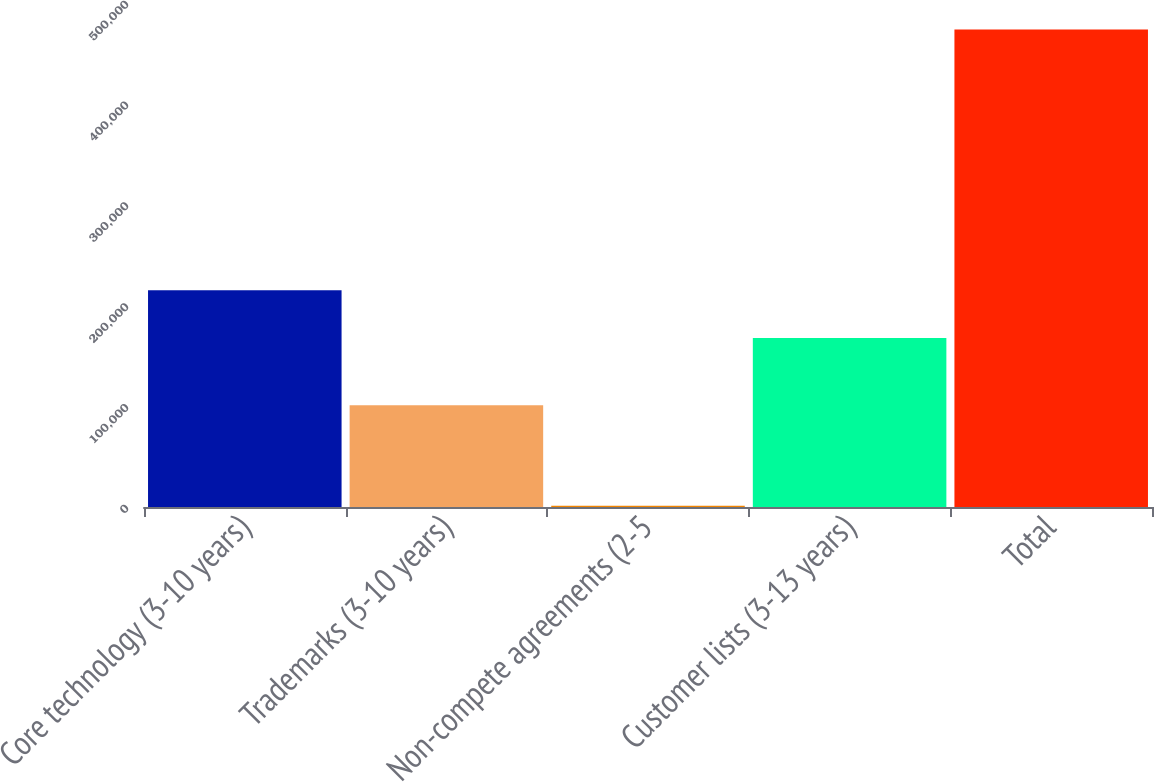<chart> <loc_0><loc_0><loc_500><loc_500><bar_chart><fcel>Core technology (3-10 years)<fcel>Trademarks (3-10 years)<fcel>Non-compete agreements (2-5<fcel>Customer lists (3-13 years)<fcel>Total<nl><fcel>215040<fcel>100924<fcel>1164<fcel>167781<fcel>473756<nl></chart> 